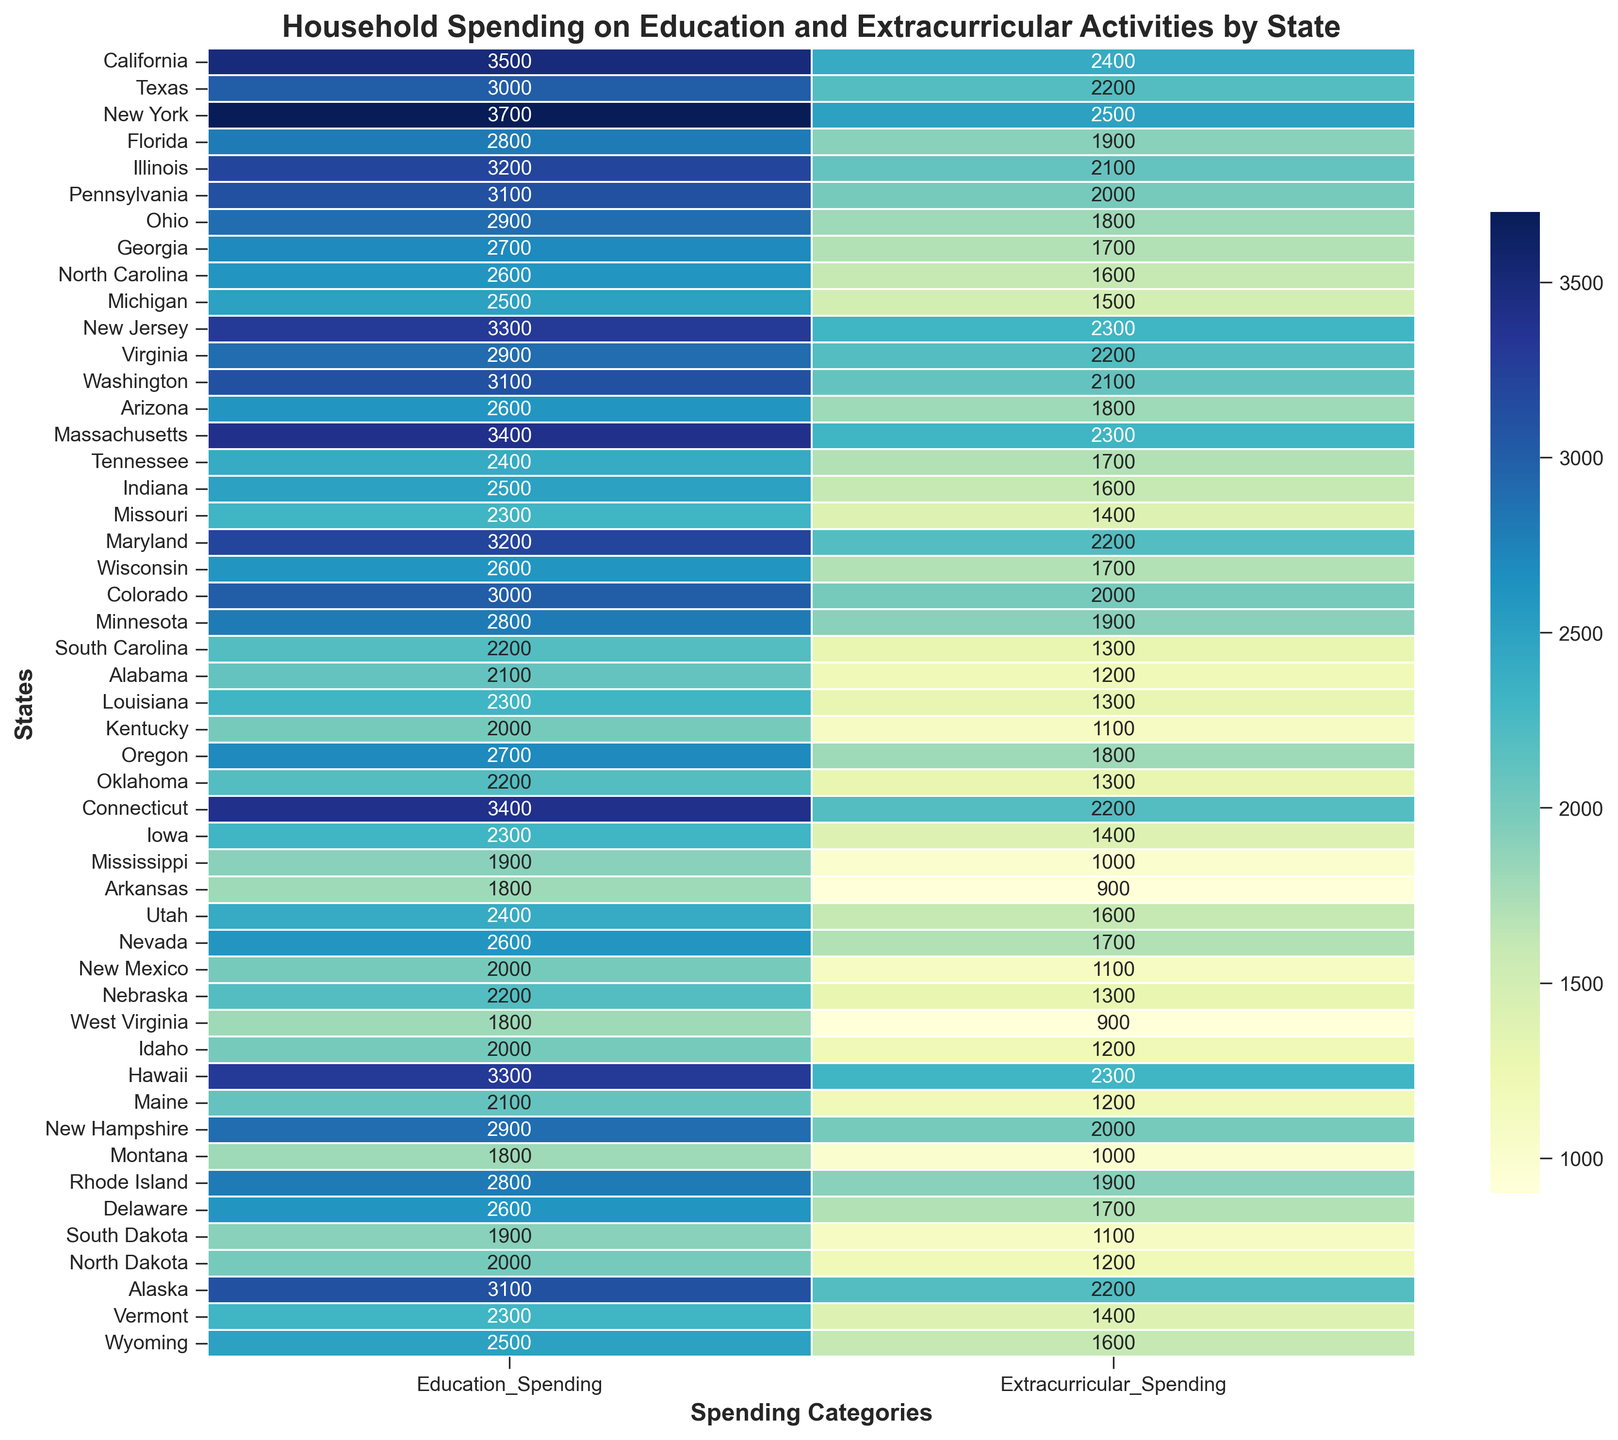What's the total household spending on education and extracurricular activities in California? To find the total spending, sum the values of the 'Education_Spending' and 'Extracurricular_Spending' for California. That's 3500 (education) + 2400 (extracurricular) = 5900.
Answer: 5900 Which state has the highest total household spending on education and extracurricular activities? Sum the 'Education_Spending' and 'Extracurricular_Spending' for each state to find the total spending. The highest total is in New York with 3700 (education) + 2500 (extracurricular) = 6200.
Answer: New York Which state has the lowest spending on extracurricular activities? Scan the 'Extracurricular_Spending' column to identify the lowest value, which is 900 in both Arkansas and West Virginia.
Answer: Arkansas and West Virginia Is the spending on education higher in Texas or Illinois? Compare the 'Education_Spending' values for Texas (3000) and Illinois (3200). Illinois has higher spending on education.
Answer: Illinois What is the average household spending on extracurricular activities across all states? Sum the 'Extracurricular_Spending' for all states and divide by the number of states. The sum is 103200, and with 50 states, the average is 103200 / 50 = 2064.
Answer: 2064 Which state has a higher combined spending on education and extracurricular activities, Florida or Washington? Calculate the total spending for both states. Florida: 2800 (education) + 1900 (extracurricular) = 4700. Washington: 3100 (education) + 2100 (extracurricular) = 5200. Washington has higher combined spending.
Answer: Washington What can you infer about the color intensity representing household spending in the heatmap? In the heatmap, darker colors typically represent higher spending values, while lighter colors indicate lower spending values.
Answer: Darker colors signify higher spending How does the spending on education in New Jersey compare to Massachusetts? Compare the 'Education_Spending' values. New Jersey spends 3300, while Massachusetts spends 3400 on education.
Answer: Massachusetts spends more What states have an equal amount of household spending on education? Compare the 'Education_Spending' values. Utah and Tennessee both have 2400 in spending on education.
Answer: Utah and Tennessee Which states have a lower household spending on education than New Hampshire? List the states with 'Education_Spending' less than 2900 (New Hampshire's value). They are Ohio, Georgia, North Carolina, Michigan, Tennessee, Indiana, Missouri, South Carolina, Alabama, Louisiana, Kentucky, Mississippi, Arkansas, New Mexico, South Dakota, North Dakota, Montana, and West Virginia.
Answer: 18 states including Ohio and Georgia 